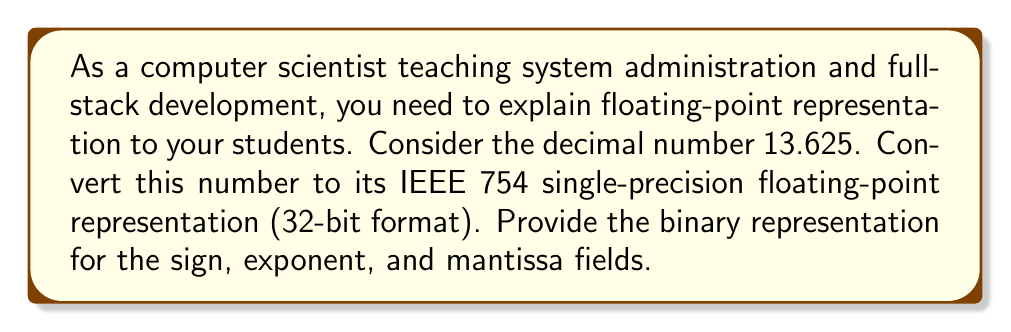Can you answer this question? To convert 13.625 to IEEE 754 single-precision format, we follow these steps:

1. Determine the sign bit:
   The number is positive, so the sign bit is 0.

2. Convert the integer and fractional parts to binary:
   Integer part: $13_{10} = 1101_2$
   Fractional part: $0.625_{10} = 0.101_2$
   
   Combining: $13.625_{10} = 1101.101_2$

3. Normalize the binary number:
   $1101.101_2 = 1.101101 \times 2^3$

4. Determine the exponent:
   The exponent is 3. In IEEE 754 single-precision, we add a bias of 127:
   $3 + 127 = 130$
   Convert 130 to binary: $130_{10} = 10000010_2$

5. Determine the mantissa:
   The mantissa is the fractional part after normalization, excluding the leading 1:
   $101101$

6. Combine the parts:
   Sign (1 bit): 0
   Exponent (8 bits): 10000010
   Mantissa (23 bits): 10110100000000000000000

   Full 32-bit representation:
   $0\ 10000010\ 10110100000000000000000$
Answer: The IEEE 754 single-precision floating-point representation of 13.625 is:

Sign: $0$
Exponent: $10000010$
Mantissa: $10110100000000000000000$

Full 32-bit representation: $0\ 10000010\ 10110100000000000000000$ 